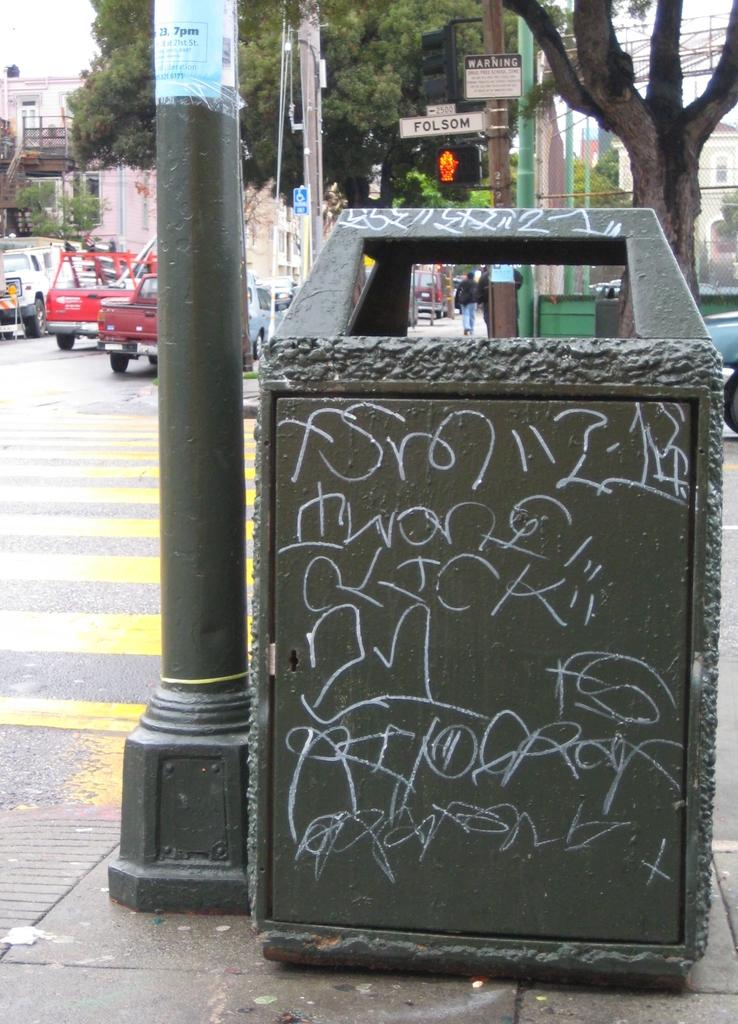What object is present in the image that is typically used for waste disposal? There is a bin in the image. What structures can be seen in the image that are used for supporting or holding up objects? There are poles in the image. What type of pathway is visible on the left side of the image? There is a road on the left side of the image. What vehicles can be seen traveling on the road? Cars are visible on the road. What activity are people engaged in within the image? There are people walking in the image. What type of natural elements can be seen in the background of the image? There are trees in the background of the image. What type of man-made structures can be seen in the background of the image? There are buildings in the background of the image. What part of the natural environment is visible in the background of the image? The sky is visible in the background of the image. What type of disease is being spread by the passenger in the image? There is no passenger present in the image, and therefore no disease can be spread. How does the person push the bin in the image? There is no person pushing the bin in the image; it is stationary. 